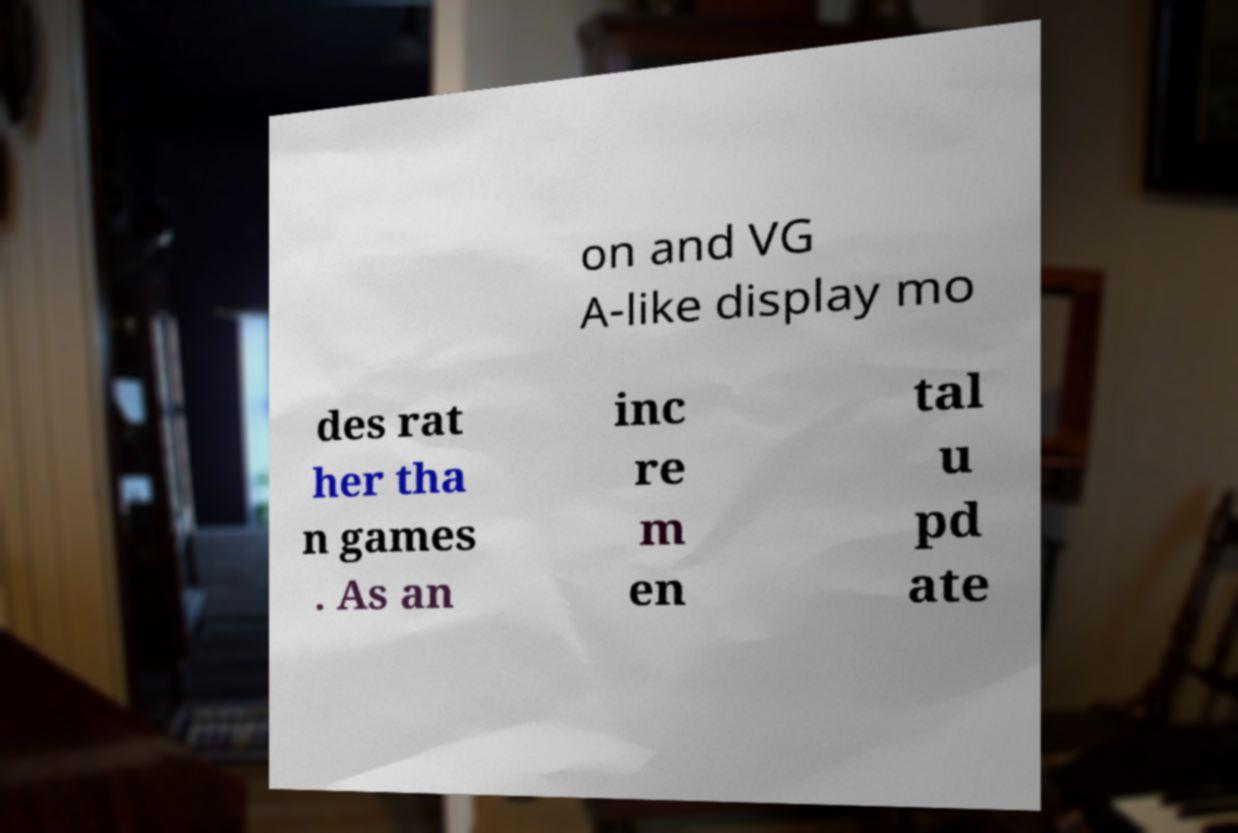I need the written content from this picture converted into text. Can you do that? on and VG A-like display mo des rat her tha n games . As an inc re m en tal u pd ate 